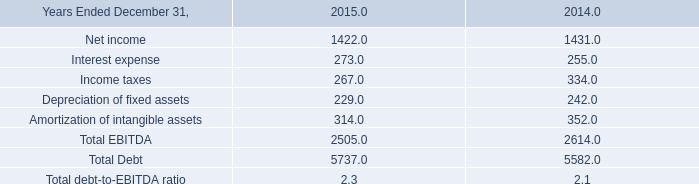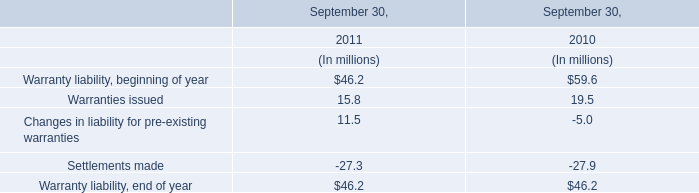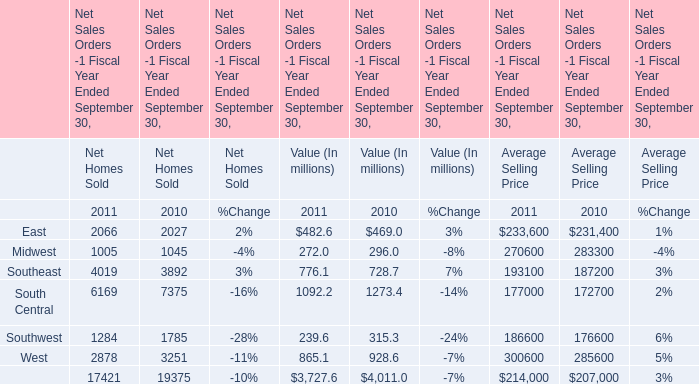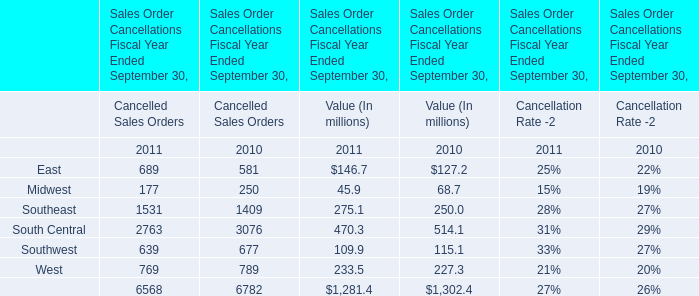what was the percent of the change in the interest expense from 2014 to 2015 
Computations: ((273 - 255) / 255)
Answer: 0.07059. 